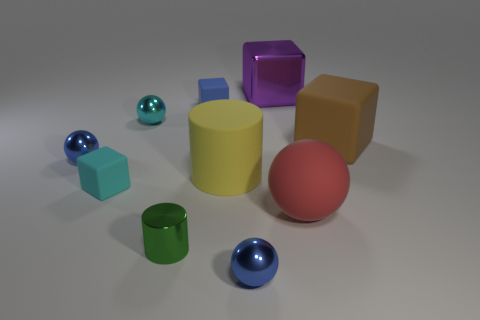Subtract all small cyan blocks. How many blocks are left? 3 Subtract all brown cubes. How many cubes are left? 3 Subtract all spheres. How many objects are left? 6 Subtract 1 blocks. How many blocks are left? 3 Subtract all brown cylinders. Subtract all brown blocks. How many cylinders are left? 2 Subtract all red spheres. How many brown blocks are left? 1 Subtract all large gray rubber things. Subtract all small blue rubber things. How many objects are left? 9 Add 5 tiny blue things. How many tiny blue things are left? 8 Add 7 small purple cylinders. How many small purple cylinders exist? 7 Subtract 1 cyan cubes. How many objects are left? 9 